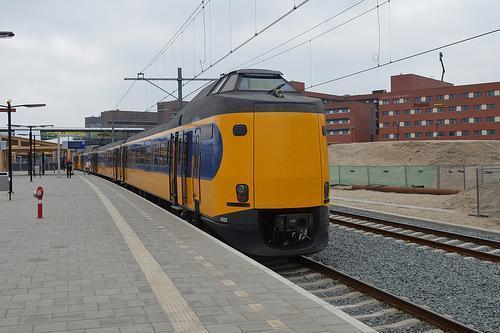How many streetlights are there?
Give a very brief answer. 2. How many people are there?
Give a very brief answer. 2. 